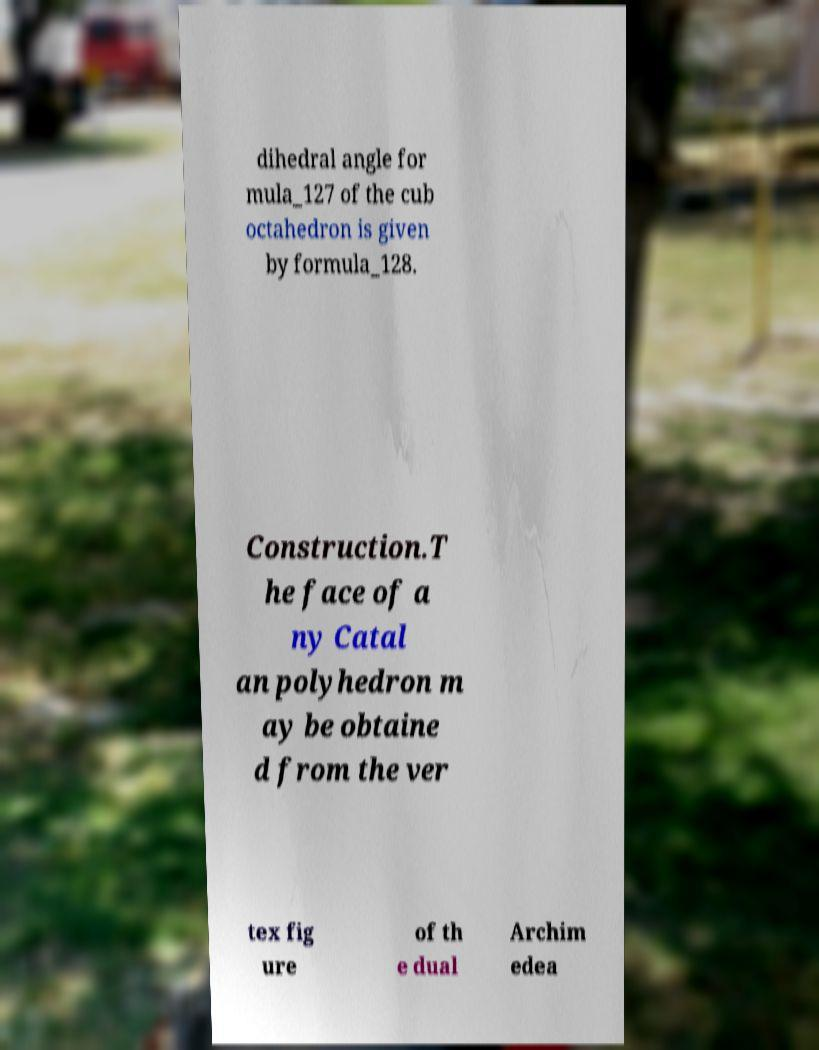For documentation purposes, I need the text within this image transcribed. Could you provide that? dihedral angle for mula_127 of the cub octahedron is given by formula_128. Construction.T he face of a ny Catal an polyhedron m ay be obtaine d from the ver tex fig ure of th e dual Archim edea 